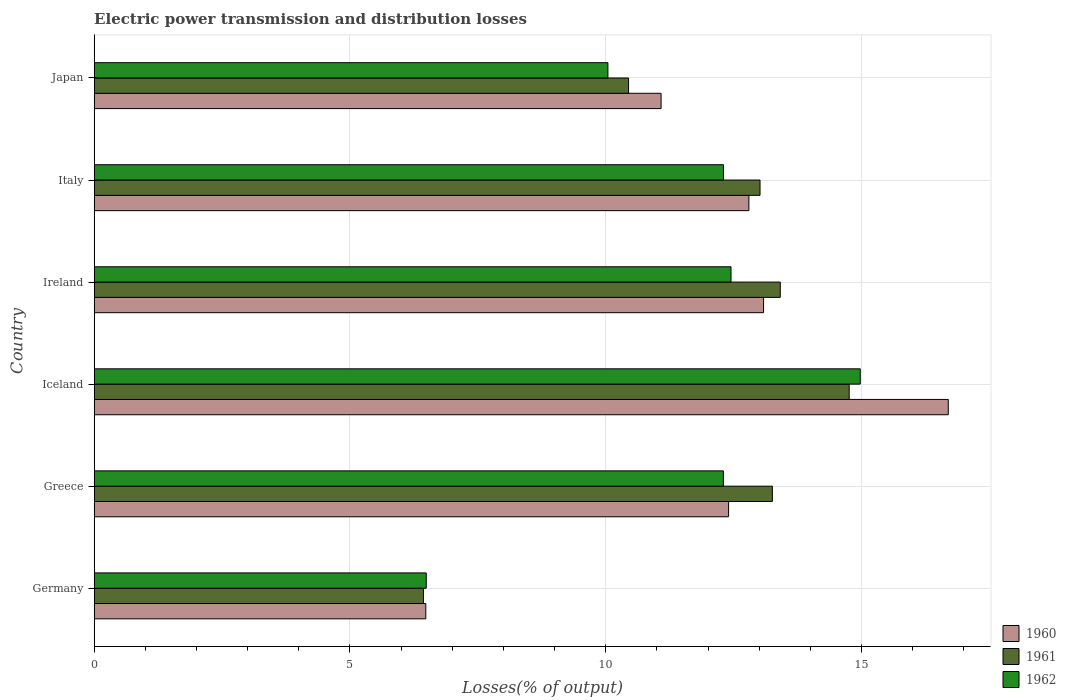What is the electric power transmission and distribution losses in 1961 in Ireland?
Offer a terse response. 13.41. Across all countries, what is the maximum electric power transmission and distribution losses in 1961?
Your answer should be compact. 14.76. Across all countries, what is the minimum electric power transmission and distribution losses in 1962?
Provide a short and direct response. 6.49. What is the total electric power transmission and distribution losses in 1962 in the graph?
Offer a terse response. 68.56. What is the difference between the electric power transmission and distribution losses in 1962 in Germany and that in Iceland?
Make the answer very short. -8.48. What is the difference between the electric power transmission and distribution losses in 1961 in Japan and the electric power transmission and distribution losses in 1962 in Ireland?
Your answer should be very brief. -2. What is the average electric power transmission and distribution losses in 1960 per country?
Ensure brevity in your answer.  12.09. What is the difference between the electric power transmission and distribution losses in 1960 and electric power transmission and distribution losses in 1962 in Iceland?
Keep it short and to the point. 1.72. What is the ratio of the electric power transmission and distribution losses in 1962 in Germany to that in Greece?
Ensure brevity in your answer.  0.53. Is the electric power transmission and distribution losses in 1960 in Greece less than that in Ireland?
Offer a terse response. Yes. Is the difference between the electric power transmission and distribution losses in 1960 in Germany and Greece greater than the difference between the electric power transmission and distribution losses in 1962 in Germany and Greece?
Keep it short and to the point. No. What is the difference between the highest and the second highest electric power transmission and distribution losses in 1960?
Your answer should be compact. 3.61. What is the difference between the highest and the lowest electric power transmission and distribution losses in 1960?
Provide a succinct answer. 10.21. In how many countries, is the electric power transmission and distribution losses in 1962 greater than the average electric power transmission and distribution losses in 1962 taken over all countries?
Your answer should be compact. 4. How many bars are there?
Offer a very short reply. 18. Are all the bars in the graph horizontal?
Your answer should be very brief. Yes. How many countries are there in the graph?
Offer a very short reply. 6. Does the graph contain any zero values?
Offer a very short reply. No. Where does the legend appear in the graph?
Your response must be concise. Bottom right. How are the legend labels stacked?
Your response must be concise. Vertical. What is the title of the graph?
Offer a very short reply. Electric power transmission and distribution losses. Does "1978" appear as one of the legend labels in the graph?
Offer a very short reply. No. What is the label or title of the X-axis?
Your answer should be compact. Losses(% of output). What is the Losses(% of output) of 1960 in Germany?
Make the answer very short. 6.48. What is the Losses(% of output) in 1961 in Germany?
Provide a succinct answer. 6.44. What is the Losses(% of output) of 1962 in Germany?
Keep it short and to the point. 6.49. What is the Losses(% of output) in 1960 in Greece?
Offer a terse response. 12.4. What is the Losses(% of output) in 1961 in Greece?
Keep it short and to the point. 13.26. What is the Losses(% of output) in 1962 in Greece?
Provide a succinct answer. 12.3. What is the Losses(% of output) of 1960 in Iceland?
Provide a succinct answer. 16.7. What is the Losses(% of output) of 1961 in Iceland?
Offer a terse response. 14.76. What is the Losses(% of output) in 1962 in Iceland?
Provide a short and direct response. 14.98. What is the Losses(% of output) of 1960 in Ireland?
Provide a succinct answer. 13.09. What is the Losses(% of output) in 1961 in Ireland?
Make the answer very short. 13.41. What is the Losses(% of output) in 1962 in Ireland?
Keep it short and to the point. 12.45. What is the Losses(% of output) in 1960 in Italy?
Provide a succinct answer. 12.8. What is the Losses(% of output) in 1961 in Italy?
Offer a very short reply. 13.02. What is the Losses(% of output) of 1962 in Italy?
Provide a short and direct response. 12.3. What is the Losses(% of output) in 1960 in Japan?
Keep it short and to the point. 11.08. What is the Losses(% of output) in 1961 in Japan?
Your answer should be very brief. 10.45. What is the Losses(% of output) of 1962 in Japan?
Provide a succinct answer. 10.04. Across all countries, what is the maximum Losses(% of output) in 1960?
Provide a short and direct response. 16.7. Across all countries, what is the maximum Losses(% of output) of 1961?
Offer a terse response. 14.76. Across all countries, what is the maximum Losses(% of output) in 1962?
Make the answer very short. 14.98. Across all countries, what is the minimum Losses(% of output) of 1960?
Offer a terse response. 6.48. Across all countries, what is the minimum Losses(% of output) in 1961?
Offer a very short reply. 6.44. Across all countries, what is the minimum Losses(% of output) of 1962?
Offer a very short reply. 6.49. What is the total Losses(% of output) of 1960 in the graph?
Make the answer very short. 72.55. What is the total Losses(% of output) of 1961 in the graph?
Offer a very short reply. 71.33. What is the total Losses(% of output) in 1962 in the graph?
Ensure brevity in your answer.  68.56. What is the difference between the Losses(% of output) in 1960 in Germany and that in Greece?
Your answer should be very brief. -5.92. What is the difference between the Losses(% of output) of 1961 in Germany and that in Greece?
Ensure brevity in your answer.  -6.82. What is the difference between the Losses(% of output) of 1962 in Germany and that in Greece?
Ensure brevity in your answer.  -5.81. What is the difference between the Losses(% of output) of 1960 in Germany and that in Iceland?
Your answer should be compact. -10.21. What is the difference between the Losses(% of output) of 1961 in Germany and that in Iceland?
Your answer should be compact. -8.32. What is the difference between the Losses(% of output) of 1962 in Germany and that in Iceland?
Your answer should be compact. -8.48. What is the difference between the Losses(% of output) of 1960 in Germany and that in Ireland?
Your response must be concise. -6.6. What is the difference between the Losses(% of output) in 1961 in Germany and that in Ireland?
Keep it short and to the point. -6.98. What is the difference between the Losses(% of output) of 1962 in Germany and that in Ireland?
Offer a very short reply. -5.96. What is the difference between the Losses(% of output) of 1960 in Germany and that in Italy?
Offer a very short reply. -6.32. What is the difference between the Losses(% of output) of 1961 in Germany and that in Italy?
Provide a succinct answer. -6.58. What is the difference between the Losses(% of output) of 1962 in Germany and that in Italy?
Your answer should be very brief. -5.81. What is the difference between the Losses(% of output) of 1960 in Germany and that in Japan?
Provide a short and direct response. -4.6. What is the difference between the Losses(% of output) of 1961 in Germany and that in Japan?
Your answer should be compact. -4.01. What is the difference between the Losses(% of output) in 1962 in Germany and that in Japan?
Your answer should be very brief. -3.55. What is the difference between the Losses(% of output) in 1960 in Greece and that in Iceland?
Your answer should be compact. -4.3. What is the difference between the Losses(% of output) of 1961 in Greece and that in Iceland?
Keep it short and to the point. -1.5. What is the difference between the Losses(% of output) of 1962 in Greece and that in Iceland?
Your response must be concise. -2.68. What is the difference between the Losses(% of output) in 1960 in Greece and that in Ireland?
Provide a short and direct response. -0.68. What is the difference between the Losses(% of output) in 1961 in Greece and that in Ireland?
Provide a succinct answer. -0.15. What is the difference between the Losses(% of output) of 1962 in Greece and that in Ireland?
Provide a short and direct response. -0.15. What is the difference between the Losses(% of output) of 1960 in Greece and that in Italy?
Provide a succinct answer. -0.4. What is the difference between the Losses(% of output) in 1961 in Greece and that in Italy?
Your answer should be compact. 0.24. What is the difference between the Losses(% of output) of 1962 in Greece and that in Italy?
Offer a terse response. -0. What is the difference between the Losses(% of output) in 1960 in Greece and that in Japan?
Your response must be concise. 1.32. What is the difference between the Losses(% of output) of 1961 in Greece and that in Japan?
Your answer should be compact. 2.81. What is the difference between the Losses(% of output) of 1962 in Greece and that in Japan?
Provide a succinct answer. 2.26. What is the difference between the Losses(% of output) in 1960 in Iceland and that in Ireland?
Ensure brevity in your answer.  3.61. What is the difference between the Losses(% of output) of 1961 in Iceland and that in Ireland?
Offer a very short reply. 1.35. What is the difference between the Losses(% of output) in 1962 in Iceland and that in Ireland?
Your response must be concise. 2.53. What is the difference between the Losses(% of output) of 1960 in Iceland and that in Italy?
Provide a succinct answer. 3.9. What is the difference between the Losses(% of output) of 1961 in Iceland and that in Italy?
Provide a succinct answer. 1.74. What is the difference between the Losses(% of output) of 1962 in Iceland and that in Italy?
Make the answer very short. 2.67. What is the difference between the Losses(% of output) in 1960 in Iceland and that in Japan?
Make the answer very short. 5.61. What is the difference between the Losses(% of output) of 1961 in Iceland and that in Japan?
Keep it short and to the point. 4.31. What is the difference between the Losses(% of output) in 1962 in Iceland and that in Japan?
Provide a short and direct response. 4.93. What is the difference between the Losses(% of output) in 1960 in Ireland and that in Italy?
Provide a short and direct response. 0.29. What is the difference between the Losses(% of output) in 1961 in Ireland and that in Italy?
Ensure brevity in your answer.  0.4. What is the difference between the Losses(% of output) of 1962 in Ireland and that in Italy?
Offer a very short reply. 0.15. What is the difference between the Losses(% of output) in 1960 in Ireland and that in Japan?
Your answer should be compact. 2. What is the difference between the Losses(% of output) of 1961 in Ireland and that in Japan?
Make the answer very short. 2.97. What is the difference between the Losses(% of output) of 1962 in Ireland and that in Japan?
Ensure brevity in your answer.  2.41. What is the difference between the Losses(% of output) in 1960 in Italy and that in Japan?
Keep it short and to the point. 1.72. What is the difference between the Losses(% of output) of 1961 in Italy and that in Japan?
Give a very brief answer. 2.57. What is the difference between the Losses(% of output) in 1962 in Italy and that in Japan?
Offer a terse response. 2.26. What is the difference between the Losses(% of output) of 1960 in Germany and the Losses(% of output) of 1961 in Greece?
Give a very brief answer. -6.78. What is the difference between the Losses(% of output) of 1960 in Germany and the Losses(% of output) of 1962 in Greece?
Ensure brevity in your answer.  -5.82. What is the difference between the Losses(% of output) in 1961 in Germany and the Losses(% of output) in 1962 in Greece?
Ensure brevity in your answer.  -5.86. What is the difference between the Losses(% of output) of 1960 in Germany and the Losses(% of output) of 1961 in Iceland?
Your response must be concise. -8.28. What is the difference between the Losses(% of output) in 1960 in Germany and the Losses(% of output) in 1962 in Iceland?
Make the answer very short. -8.49. What is the difference between the Losses(% of output) in 1961 in Germany and the Losses(% of output) in 1962 in Iceland?
Make the answer very short. -8.54. What is the difference between the Losses(% of output) of 1960 in Germany and the Losses(% of output) of 1961 in Ireland?
Ensure brevity in your answer.  -6.93. What is the difference between the Losses(% of output) in 1960 in Germany and the Losses(% of output) in 1962 in Ireland?
Give a very brief answer. -5.97. What is the difference between the Losses(% of output) in 1961 in Germany and the Losses(% of output) in 1962 in Ireland?
Offer a terse response. -6.01. What is the difference between the Losses(% of output) of 1960 in Germany and the Losses(% of output) of 1961 in Italy?
Keep it short and to the point. -6.53. What is the difference between the Losses(% of output) in 1960 in Germany and the Losses(% of output) in 1962 in Italy?
Make the answer very short. -5.82. What is the difference between the Losses(% of output) in 1961 in Germany and the Losses(% of output) in 1962 in Italy?
Your answer should be compact. -5.87. What is the difference between the Losses(% of output) of 1960 in Germany and the Losses(% of output) of 1961 in Japan?
Your answer should be very brief. -3.96. What is the difference between the Losses(% of output) of 1960 in Germany and the Losses(% of output) of 1962 in Japan?
Provide a short and direct response. -3.56. What is the difference between the Losses(% of output) of 1961 in Germany and the Losses(% of output) of 1962 in Japan?
Your response must be concise. -3.61. What is the difference between the Losses(% of output) of 1960 in Greece and the Losses(% of output) of 1961 in Iceland?
Offer a terse response. -2.36. What is the difference between the Losses(% of output) in 1960 in Greece and the Losses(% of output) in 1962 in Iceland?
Offer a terse response. -2.57. What is the difference between the Losses(% of output) of 1961 in Greece and the Losses(% of output) of 1962 in Iceland?
Keep it short and to the point. -1.72. What is the difference between the Losses(% of output) of 1960 in Greece and the Losses(% of output) of 1961 in Ireland?
Provide a succinct answer. -1.01. What is the difference between the Losses(% of output) in 1960 in Greece and the Losses(% of output) in 1962 in Ireland?
Make the answer very short. -0.05. What is the difference between the Losses(% of output) in 1961 in Greece and the Losses(% of output) in 1962 in Ireland?
Ensure brevity in your answer.  0.81. What is the difference between the Losses(% of output) of 1960 in Greece and the Losses(% of output) of 1961 in Italy?
Your response must be concise. -0.61. What is the difference between the Losses(% of output) of 1960 in Greece and the Losses(% of output) of 1962 in Italy?
Offer a terse response. 0.1. What is the difference between the Losses(% of output) in 1961 in Greece and the Losses(% of output) in 1962 in Italy?
Provide a short and direct response. 0.96. What is the difference between the Losses(% of output) of 1960 in Greece and the Losses(% of output) of 1961 in Japan?
Give a very brief answer. 1.96. What is the difference between the Losses(% of output) of 1960 in Greece and the Losses(% of output) of 1962 in Japan?
Give a very brief answer. 2.36. What is the difference between the Losses(% of output) in 1961 in Greece and the Losses(% of output) in 1962 in Japan?
Your response must be concise. 3.22. What is the difference between the Losses(% of output) in 1960 in Iceland and the Losses(% of output) in 1961 in Ireland?
Your response must be concise. 3.28. What is the difference between the Losses(% of output) in 1960 in Iceland and the Losses(% of output) in 1962 in Ireland?
Give a very brief answer. 4.25. What is the difference between the Losses(% of output) of 1961 in Iceland and the Losses(% of output) of 1962 in Ireland?
Give a very brief answer. 2.31. What is the difference between the Losses(% of output) in 1960 in Iceland and the Losses(% of output) in 1961 in Italy?
Provide a short and direct response. 3.68. What is the difference between the Losses(% of output) of 1960 in Iceland and the Losses(% of output) of 1962 in Italy?
Give a very brief answer. 4.39. What is the difference between the Losses(% of output) of 1961 in Iceland and the Losses(% of output) of 1962 in Italy?
Keep it short and to the point. 2.46. What is the difference between the Losses(% of output) of 1960 in Iceland and the Losses(% of output) of 1961 in Japan?
Ensure brevity in your answer.  6.25. What is the difference between the Losses(% of output) of 1960 in Iceland and the Losses(% of output) of 1962 in Japan?
Your answer should be very brief. 6.65. What is the difference between the Losses(% of output) in 1961 in Iceland and the Losses(% of output) in 1962 in Japan?
Keep it short and to the point. 4.72. What is the difference between the Losses(% of output) in 1960 in Ireland and the Losses(% of output) in 1961 in Italy?
Keep it short and to the point. 0.07. What is the difference between the Losses(% of output) in 1960 in Ireland and the Losses(% of output) in 1962 in Italy?
Offer a terse response. 0.78. What is the difference between the Losses(% of output) of 1961 in Ireland and the Losses(% of output) of 1962 in Italy?
Ensure brevity in your answer.  1.11. What is the difference between the Losses(% of output) in 1960 in Ireland and the Losses(% of output) in 1961 in Japan?
Make the answer very short. 2.64. What is the difference between the Losses(% of output) of 1960 in Ireland and the Losses(% of output) of 1962 in Japan?
Provide a succinct answer. 3.04. What is the difference between the Losses(% of output) of 1961 in Ireland and the Losses(% of output) of 1962 in Japan?
Your answer should be very brief. 3.37. What is the difference between the Losses(% of output) in 1960 in Italy and the Losses(% of output) in 1961 in Japan?
Offer a very short reply. 2.35. What is the difference between the Losses(% of output) of 1960 in Italy and the Losses(% of output) of 1962 in Japan?
Make the answer very short. 2.76. What is the difference between the Losses(% of output) of 1961 in Italy and the Losses(% of output) of 1962 in Japan?
Provide a short and direct response. 2.97. What is the average Losses(% of output) in 1960 per country?
Your response must be concise. 12.09. What is the average Losses(% of output) of 1961 per country?
Your answer should be very brief. 11.89. What is the average Losses(% of output) of 1962 per country?
Keep it short and to the point. 11.43. What is the difference between the Losses(% of output) in 1960 and Losses(% of output) in 1961 in Germany?
Provide a short and direct response. 0.05. What is the difference between the Losses(% of output) in 1960 and Losses(% of output) in 1962 in Germany?
Offer a terse response. -0.01. What is the difference between the Losses(% of output) of 1961 and Losses(% of output) of 1962 in Germany?
Make the answer very short. -0.06. What is the difference between the Losses(% of output) in 1960 and Losses(% of output) in 1961 in Greece?
Your response must be concise. -0.86. What is the difference between the Losses(% of output) of 1960 and Losses(% of output) of 1962 in Greece?
Keep it short and to the point. 0.1. What is the difference between the Losses(% of output) in 1961 and Losses(% of output) in 1962 in Greece?
Make the answer very short. 0.96. What is the difference between the Losses(% of output) in 1960 and Losses(% of output) in 1961 in Iceland?
Provide a short and direct response. 1.94. What is the difference between the Losses(% of output) of 1960 and Losses(% of output) of 1962 in Iceland?
Make the answer very short. 1.72. What is the difference between the Losses(% of output) in 1961 and Losses(% of output) in 1962 in Iceland?
Give a very brief answer. -0.22. What is the difference between the Losses(% of output) in 1960 and Losses(% of output) in 1961 in Ireland?
Give a very brief answer. -0.33. What is the difference between the Losses(% of output) in 1960 and Losses(% of output) in 1962 in Ireland?
Provide a succinct answer. 0.64. What is the difference between the Losses(% of output) in 1961 and Losses(% of output) in 1962 in Ireland?
Make the answer very short. 0.96. What is the difference between the Losses(% of output) in 1960 and Losses(% of output) in 1961 in Italy?
Give a very brief answer. -0.22. What is the difference between the Losses(% of output) in 1960 and Losses(% of output) in 1962 in Italy?
Offer a very short reply. 0.5. What is the difference between the Losses(% of output) in 1961 and Losses(% of output) in 1962 in Italy?
Provide a short and direct response. 0.71. What is the difference between the Losses(% of output) in 1960 and Losses(% of output) in 1961 in Japan?
Give a very brief answer. 0.64. What is the difference between the Losses(% of output) of 1960 and Losses(% of output) of 1962 in Japan?
Offer a very short reply. 1.04. What is the difference between the Losses(% of output) in 1961 and Losses(% of output) in 1962 in Japan?
Keep it short and to the point. 0.4. What is the ratio of the Losses(% of output) in 1960 in Germany to that in Greece?
Keep it short and to the point. 0.52. What is the ratio of the Losses(% of output) of 1961 in Germany to that in Greece?
Provide a succinct answer. 0.49. What is the ratio of the Losses(% of output) in 1962 in Germany to that in Greece?
Your answer should be very brief. 0.53. What is the ratio of the Losses(% of output) in 1960 in Germany to that in Iceland?
Provide a succinct answer. 0.39. What is the ratio of the Losses(% of output) in 1961 in Germany to that in Iceland?
Your answer should be compact. 0.44. What is the ratio of the Losses(% of output) in 1962 in Germany to that in Iceland?
Give a very brief answer. 0.43. What is the ratio of the Losses(% of output) of 1960 in Germany to that in Ireland?
Your response must be concise. 0.5. What is the ratio of the Losses(% of output) of 1961 in Germany to that in Ireland?
Ensure brevity in your answer.  0.48. What is the ratio of the Losses(% of output) in 1962 in Germany to that in Ireland?
Your answer should be compact. 0.52. What is the ratio of the Losses(% of output) of 1960 in Germany to that in Italy?
Keep it short and to the point. 0.51. What is the ratio of the Losses(% of output) in 1961 in Germany to that in Italy?
Give a very brief answer. 0.49. What is the ratio of the Losses(% of output) in 1962 in Germany to that in Italy?
Your answer should be very brief. 0.53. What is the ratio of the Losses(% of output) in 1960 in Germany to that in Japan?
Your answer should be compact. 0.58. What is the ratio of the Losses(% of output) of 1961 in Germany to that in Japan?
Your answer should be very brief. 0.62. What is the ratio of the Losses(% of output) in 1962 in Germany to that in Japan?
Provide a succinct answer. 0.65. What is the ratio of the Losses(% of output) of 1960 in Greece to that in Iceland?
Offer a very short reply. 0.74. What is the ratio of the Losses(% of output) in 1961 in Greece to that in Iceland?
Your response must be concise. 0.9. What is the ratio of the Losses(% of output) of 1962 in Greece to that in Iceland?
Offer a terse response. 0.82. What is the ratio of the Losses(% of output) in 1960 in Greece to that in Ireland?
Give a very brief answer. 0.95. What is the ratio of the Losses(% of output) in 1960 in Greece to that in Italy?
Give a very brief answer. 0.97. What is the ratio of the Losses(% of output) of 1961 in Greece to that in Italy?
Provide a short and direct response. 1.02. What is the ratio of the Losses(% of output) of 1962 in Greece to that in Italy?
Provide a succinct answer. 1. What is the ratio of the Losses(% of output) in 1960 in Greece to that in Japan?
Your answer should be compact. 1.12. What is the ratio of the Losses(% of output) in 1961 in Greece to that in Japan?
Offer a very short reply. 1.27. What is the ratio of the Losses(% of output) of 1962 in Greece to that in Japan?
Your answer should be compact. 1.22. What is the ratio of the Losses(% of output) of 1960 in Iceland to that in Ireland?
Provide a succinct answer. 1.28. What is the ratio of the Losses(% of output) of 1961 in Iceland to that in Ireland?
Ensure brevity in your answer.  1.1. What is the ratio of the Losses(% of output) of 1962 in Iceland to that in Ireland?
Your response must be concise. 1.2. What is the ratio of the Losses(% of output) in 1960 in Iceland to that in Italy?
Your response must be concise. 1.3. What is the ratio of the Losses(% of output) of 1961 in Iceland to that in Italy?
Make the answer very short. 1.13. What is the ratio of the Losses(% of output) in 1962 in Iceland to that in Italy?
Your response must be concise. 1.22. What is the ratio of the Losses(% of output) of 1960 in Iceland to that in Japan?
Make the answer very short. 1.51. What is the ratio of the Losses(% of output) of 1961 in Iceland to that in Japan?
Make the answer very short. 1.41. What is the ratio of the Losses(% of output) in 1962 in Iceland to that in Japan?
Keep it short and to the point. 1.49. What is the ratio of the Losses(% of output) in 1960 in Ireland to that in Italy?
Give a very brief answer. 1.02. What is the ratio of the Losses(% of output) in 1961 in Ireland to that in Italy?
Provide a short and direct response. 1.03. What is the ratio of the Losses(% of output) of 1960 in Ireland to that in Japan?
Make the answer very short. 1.18. What is the ratio of the Losses(% of output) of 1961 in Ireland to that in Japan?
Ensure brevity in your answer.  1.28. What is the ratio of the Losses(% of output) in 1962 in Ireland to that in Japan?
Keep it short and to the point. 1.24. What is the ratio of the Losses(% of output) of 1960 in Italy to that in Japan?
Make the answer very short. 1.15. What is the ratio of the Losses(% of output) in 1961 in Italy to that in Japan?
Provide a succinct answer. 1.25. What is the ratio of the Losses(% of output) in 1962 in Italy to that in Japan?
Offer a very short reply. 1.23. What is the difference between the highest and the second highest Losses(% of output) of 1960?
Ensure brevity in your answer.  3.61. What is the difference between the highest and the second highest Losses(% of output) of 1961?
Offer a terse response. 1.35. What is the difference between the highest and the second highest Losses(% of output) in 1962?
Provide a succinct answer. 2.53. What is the difference between the highest and the lowest Losses(% of output) in 1960?
Your answer should be very brief. 10.21. What is the difference between the highest and the lowest Losses(% of output) in 1961?
Ensure brevity in your answer.  8.32. What is the difference between the highest and the lowest Losses(% of output) of 1962?
Give a very brief answer. 8.48. 